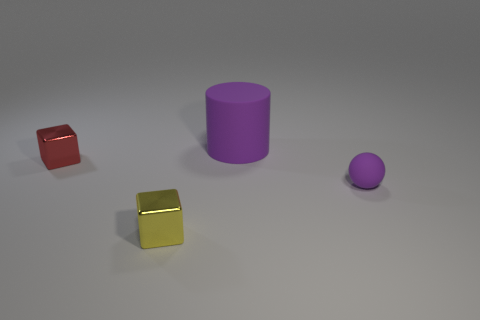Add 1 large gray rubber cylinders. How many objects exist? 5 Subtract all spheres. How many objects are left? 3 Add 4 small yellow things. How many small yellow things are left? 5 Add 1 rubber spheres. How many rubber spheres exist? 2 Subtract 0 cyan blocks. How many objects are left? 4 Subtract all red metallic cubes. Subtract all tiny yellow metallic objects. How many objects are left? 2 